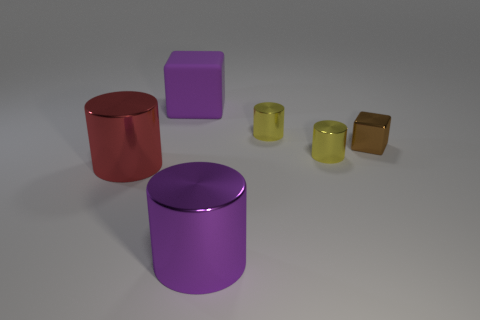How many objects are either big things to the left of the big matte block or metal objects behind the big purple metallic thing?
Offer a very short reply. 4. There is a metallic cylinder that is both right of the big purple metal cylinder and in front of the metal cube; how big is it?
Provide a short and direct response. Small. There is a purple matte object; does it have the same shape as the purple object in front of the large rubber cube?
Your answer should be compact. No. What number of things are yellow metallic cylinders behind the tiny brown metallic thing or big things?
Your response must be concise. 4. Is the material of the large red cylinder the same as the purple thing on the right side of the purple rubber block?
Offer a terse response. Yes. What shape is the brown shiny thing that is on the right side of the large thing behind the red thing?
Your response must be concise. Cube. There is a small metal block; is its color the same as the large cylinder that is left of the big purple block?
Offer a terse response. No. Is there anything else that is the same material as the purple cylinder?
Your response must be concise. Yes. The big red metal object has what shape?
Your answer should be very brief. Cylinder. There is a yellow shiny thing behind the small yellow metal object that is in front of the small brown thing; what size is it?
Provide a short and direct response. Small. 